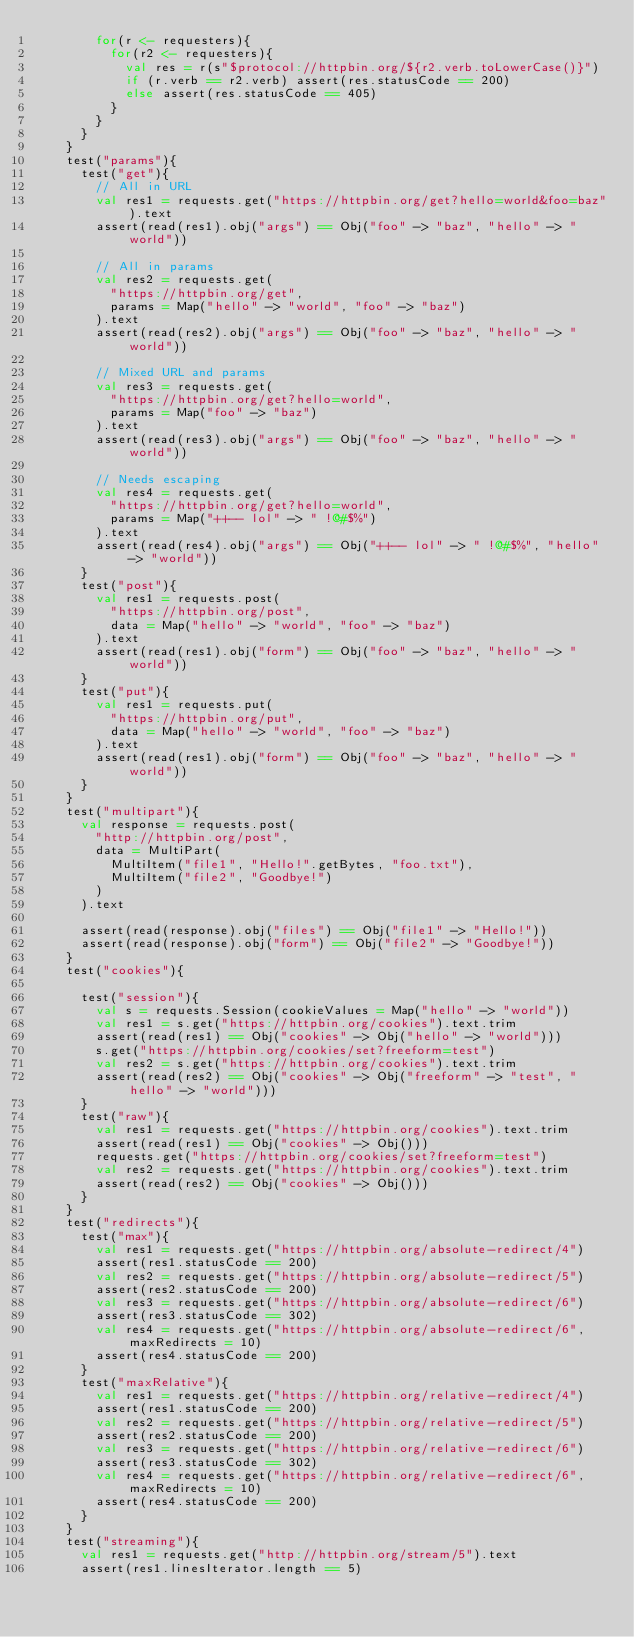Convert code to text. <code><loc_0><loc_0><loc_500><loc_500><_Scala_>        for(r <- requesters){
          for(r2 <- requesters){
            val res = r(s"$protocol://httpbin.org/${r2.verb.toLowerCase()}")
            if (r.verb == r2.verb) assert(res.statusCode == 200)
            else assert(res.statusCode == 405)
          }
        }
      }
    }
    test("params"){
      test("get"){
        // All in URL
        val res1 = requests.get("https://httpbin.org/get?hello=world&foo=baz").text
        assert(read(res1).obj("args") == Obj("foo" -> "baz", "hello" -> "world"))

        // All in params
        val res2 = requests.get(
          "https://httpbin.org/get",
          params = Map("hello" -> "world", "foo" -> "baz")
        ).text
        assert(read(res2).obj("args") == Obj("foo" -> "baz", "hello" -> "world"))

        // Mixed URL and params
        val res3 = requests.get(
          "https://httpbin.org/get?hello=world",
          params = Map("foo" -> "baz")
        ).text
        assert(read(res3).obj("args") == Obj("foo" -> "baz", "hello" -> "world"))

        // Needs escaping
        val res4 = requests.get(
          "https://httpbin.org/get?hello=world",
          params = Map("++-- lol" -> " !@#$%")
        ).text
        assert(read(res4).obj("args") == Obj("++-- lol" -> " !@#$%", "hello" -> "world"))
      }
      test("post"){
        val res1 = requests.post(
          "https://httpbin.org/post",
          data = Map("hello" -> "world", "foo" -> "baz")
        ).text
        assert(read(res1).obj("form") == Obj("foo" -> "baz", "hello" -> "world"))
      }
      test("put"){
        val res1 = requests.put(
          "https://httpbin.org/put",
          data = Map("hello" -> "world", "foo" -> "baz")
        ).text
        assert(read(res1).obj("form") == Obj("foo" -> "baz", "hello" -> "world"))
      }
    }
    test("multipart"){
      val response = requests.post(
        "http://httpbin.org/post",
        data = MultiPart(
          MultiItem("file1", "Hello!".getBytes, "foo.txt"),
          MultiItem("file2", "Goodbye!")
        )
      ).text

      assert(read(response).obj("files") == Obj("file1" -> "Hello!"))
      assert(read(response).obj("form") == Obj("file2" -> "Goodbye!"))
    }
    test("cookies"){

      test("session"){
        val s = requests.Session(cookieValues = Map("hello" -> "world"))
        val res1 = s.get("https://httpbin.org/cookies").text.trim
        assert(read(res1) == Obj("cookies" -> Obj("hello" -> "world")))
        s.get("https://httpbin.org/cookies/set?freeform=test")
        val res2 = s.get("https://httpbin.org/cookies").text.trim
        assert(read(res2) == Obj("cookies" -> Obj("freeform" -> "test", "hello" -> "world")))
      }
      test("raw"){
        val res1 = requests.get("https://httpbin.org/cookies").text.trim
        assert(read(res1) == Obj("cookies" -> Obj()))
        requests.get("https://httpbin.org/cookies/set?freeform=test")
        val res2 = requests.get("https://httpbin.org/cookies").text.trim
        assert(read(res2) == Obj("cookies" -> Obj()))
      }
    }
    test("redirects"){
      test("max"){
        val res1 = requests.get("https://httpbin.org/absolute-redirect/4")
        assert(res1.statusCode == 200)
        val res2 = requests.get("https://httpbin.org/absolute-redirect/5")
        assert(res2.statusCode == 200)
        val res3 = requests.get("https://httpbin.org/absolute-redirect/6")
        assert(res3.statusCode == 302)
        val res4 = requests.get("https://httpbin.org/absolute-redirect/6", maxRedirects = 10)
        assert(res4.statusCode == 200)
      }
      test("maxRelative"){
        val res1 = requests.get("https://httpbin.org/relative-redirect/4")
        assert(res1.statusCode == 200)
        val res2 = requests.get("https://httpbin.org/relative-redirect/5")
        assert(res2.statusCode == 200)
        val res3 = requests.get("https://httpbin.org/relative-redirect/6")
        assert(res3.statusCode == 302)
        val res4 = requests.get("https://httpbin.org/relative-redirect/6", maxRedirects = 10)
        assert(res4.statusCode == 200)
      }
    }
    test("streaming"){
      val res1 = requests.get("http://httpbin.org/stream/5").text
      assert(res1.linesIterator.length == 5)</code> 